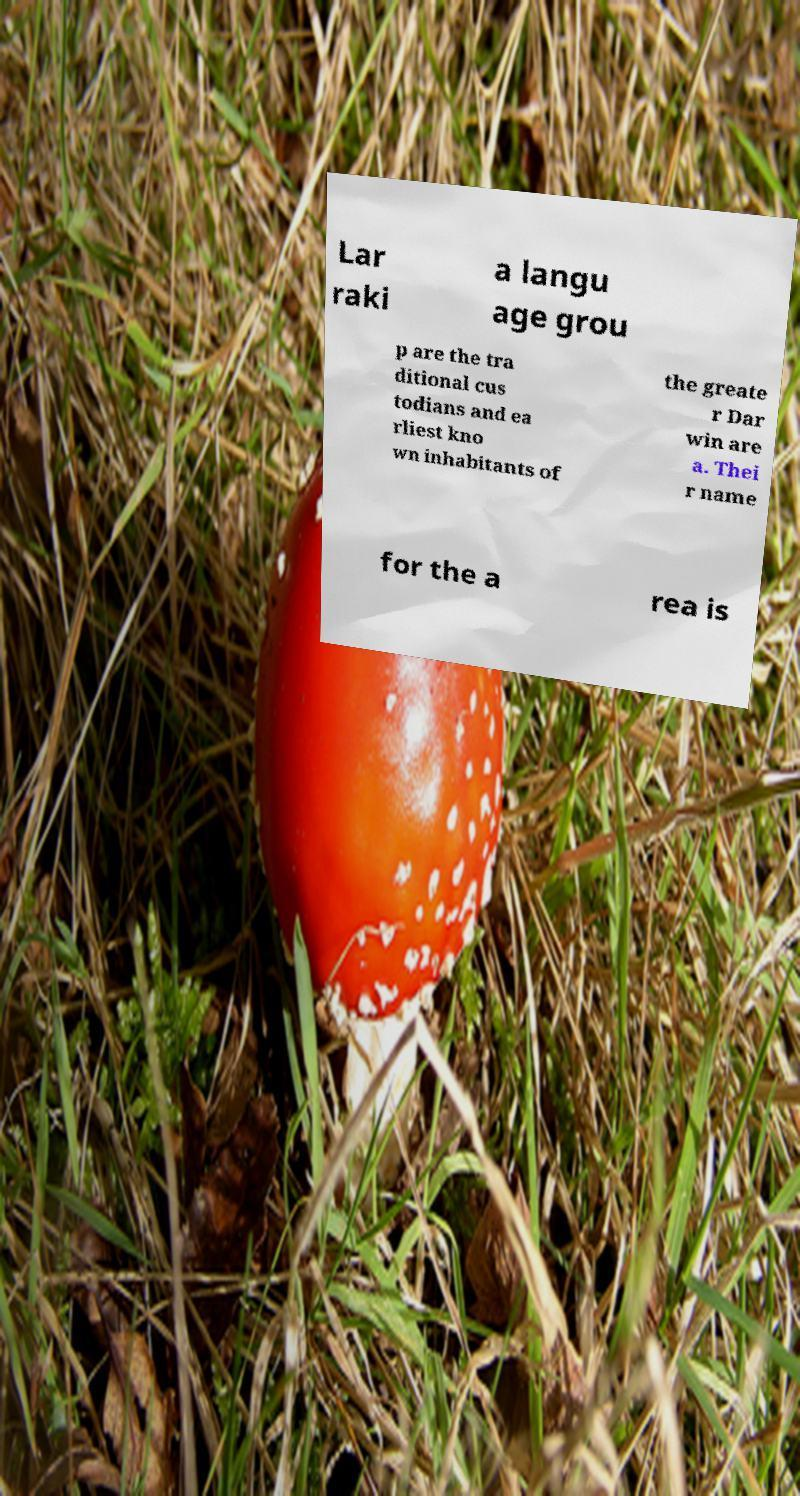Could you extract and type out the text from this image? Lar raki a langu age grou p are the tra ditional cus todians and ea rliest kno wn inhabitants of the greate r Dar win are a. Thei r name for the a rea is 